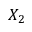Convert formula to latex. <formula><loc_0><loc_0><loc_500><loc_500>X _ { 2 }</formula> 